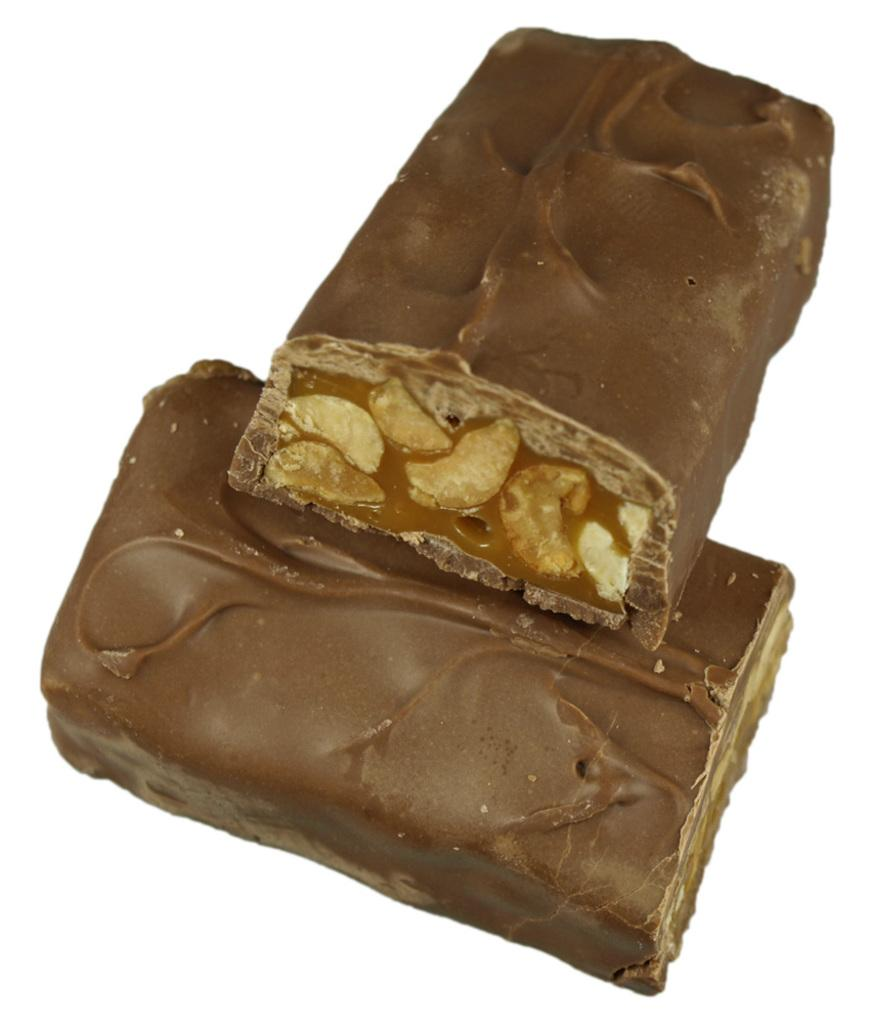What type of food items are present in the image? There are two pieces of chocolate and nuts in the image. Can you describe the nuts in the image? The nuts are visible in the image, but their specific type is not mentioned. What type of cast can be seen in the image? There is no cast present in the image. What type of cannon is visible in the image? There is no cannon present in the image. 